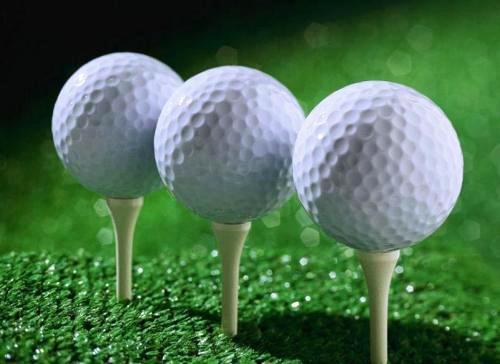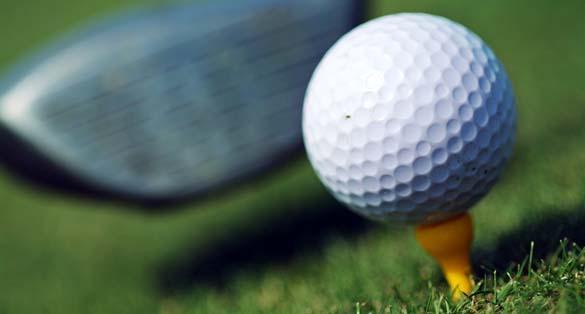The first image is the image on the left, the second image is the image on the right. Considering the images on both sides, is "An image shows an angled row of three white golf balls on tees on green carpet." valid? Answer yes or no. Yes. The first image is the image on the left, the second image is the image on the right. For the images shown, is this caption "Three balls are on tees in one of the images." true? Answer yes or no. Yes. 